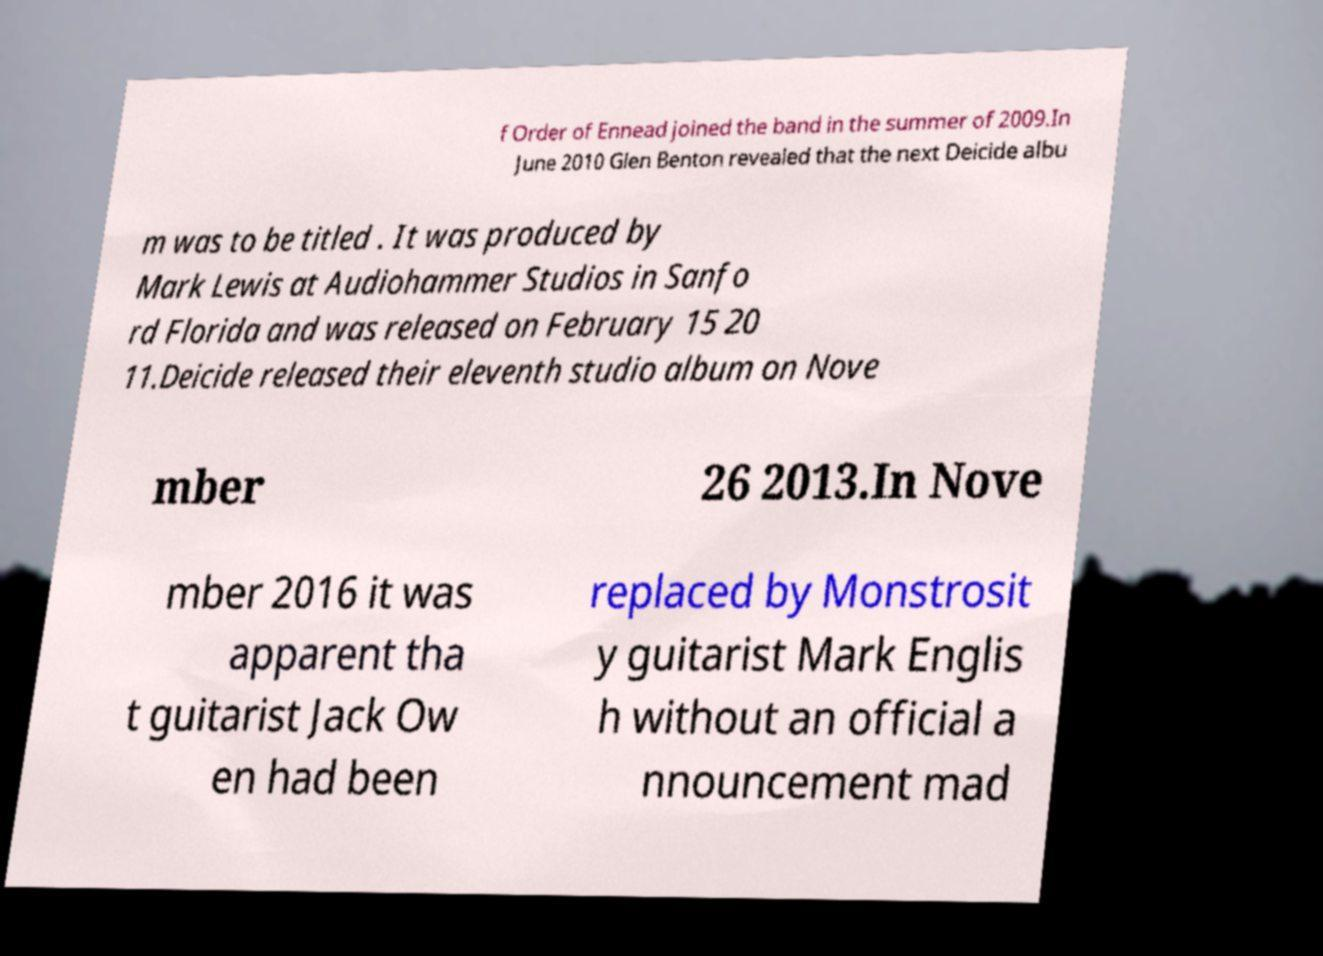Could you extract and type out the text from this image? f Order of Ennead joined the band in the summer of 2009.In June 2010 Glen Benton revealed that the next Deicide albu m was to be titled . It was produced by Mark Lewis at Audiohammer Studios in Sanfo rd Florida and was released on February 15 20 11.Deicide released their eleventh studio album on Nove mber 26 2013.In Nove mber 2016 it was apparent tha t guitarist Jack Ow en had been replaced by Monstrosit y guitarist Mark Englis h without an official a nnouncement mad 